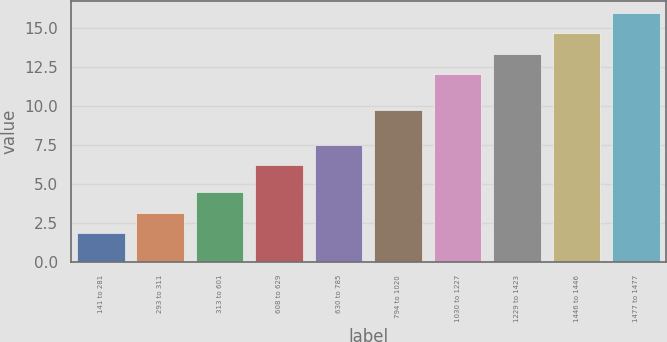<chart> <loc_0><loc_0><loc_500><loc_500><bar_chart><fcel>141 to 281<fcel>293 to 311<fcel>313 to 601<fcel>608 to 629<fcel>630 to 785<fcel>794 to 1020<fcel>1030 to 1227<fcel>1229 to 1423<fcel>1446 to 1446<fcel>1477 to 1477<nl><fcel>1.87<fcel>3.16<fcel>4.45<fcel>6.23<fcel>7.52<fcel>9.77<fcel>12.07<fcel>13.36<fcel>14.65<fcel>15.94<nl></chart> 